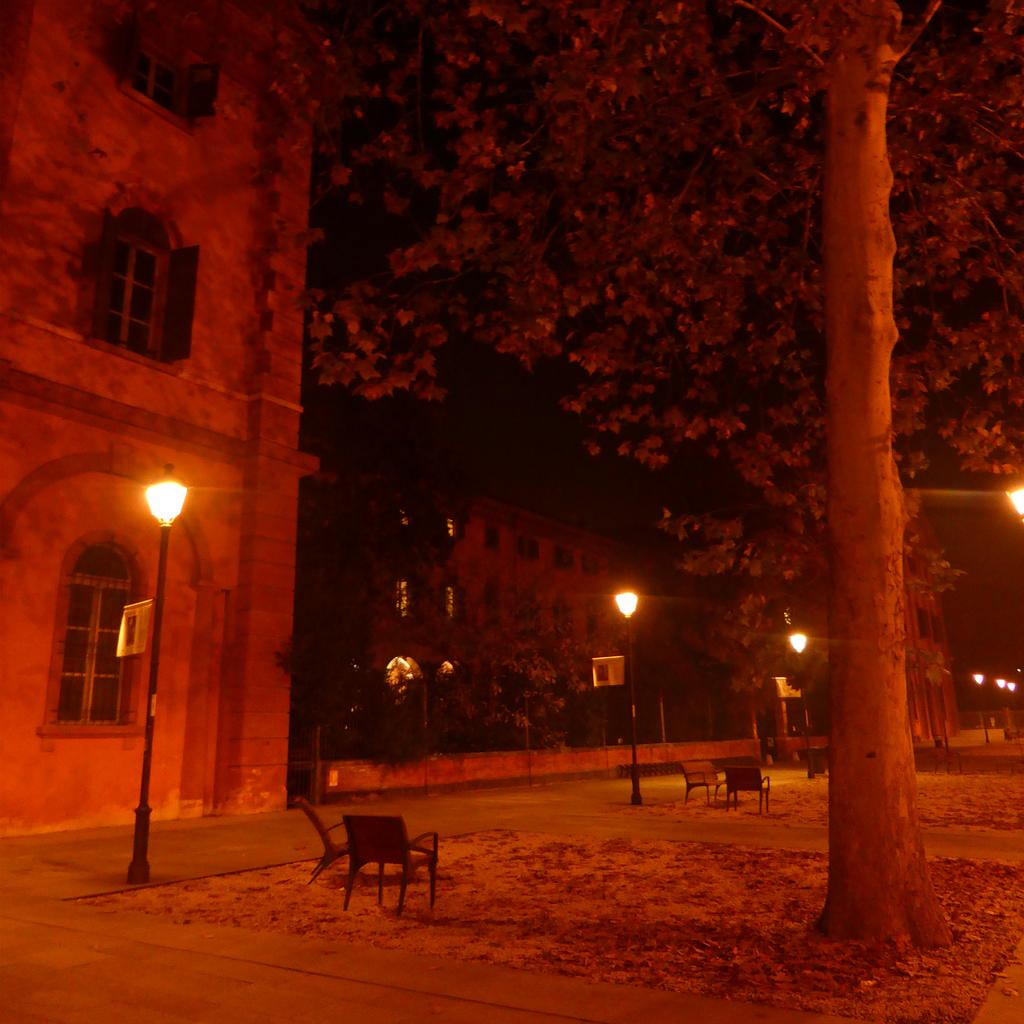What type of furniture is present in the image? There are chairs in the image. What can be seen illuminating the scene in the image? There are lights in the image. What structures are present in the image that are not part of the building? There are poles in the image. What type of natural vegetation is present in the image? There are trees in the image. What type of man-made structure is present in the image? There is a building in the image. Can you see a footprint on the ground in the image? There is no footprint visible in the image. What type of doll is sitting on the chair in the image? There is no doll present in the image. Are there any yaks grazing near the trees in the image? There are no yaks present in the image. 